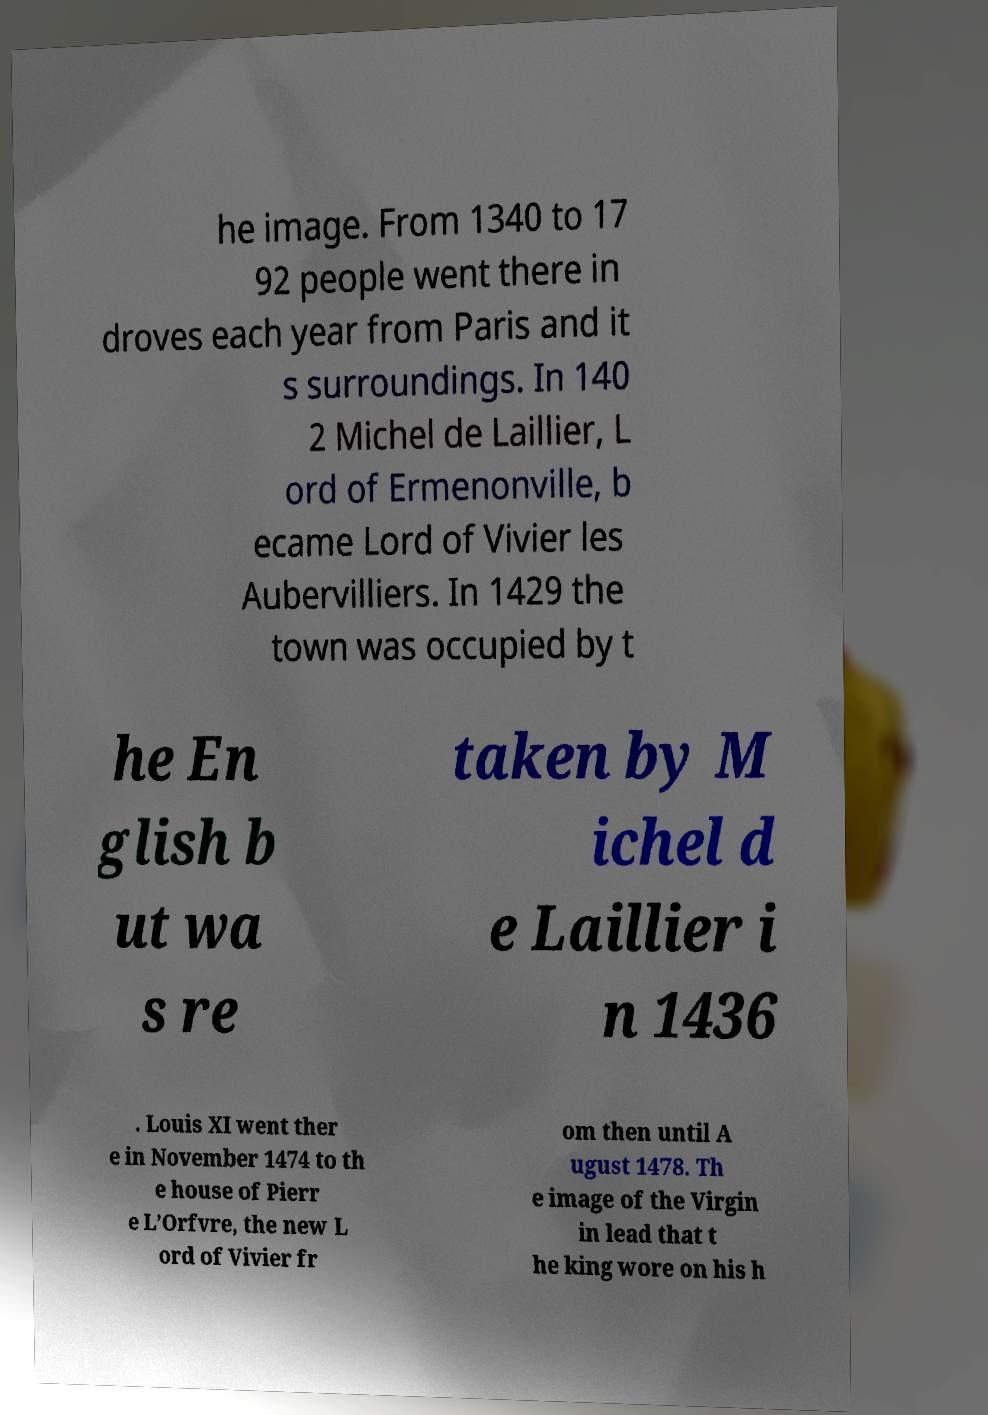I need the written content from this picture converted into text. Can you do that? he image. From 1340 to 17 92 people went there in droves each year from Paris and it s surroundings. In 140 2 Michel de Laillier, L ord of Ermenonville, b ecame Lord of Vivier les Aubervilliers. In 1429 the town was occupied by t he En glish b ut wa s re taken by M ichel d e Laillier i n 1436 . Louis XI went ther e in November 1474 to th e house of Pierr e L’Orfvre, the new L ord of Vivier fr om then until A ugust 1478. Th e image of the Virgin in lead that t he king wore on his h 